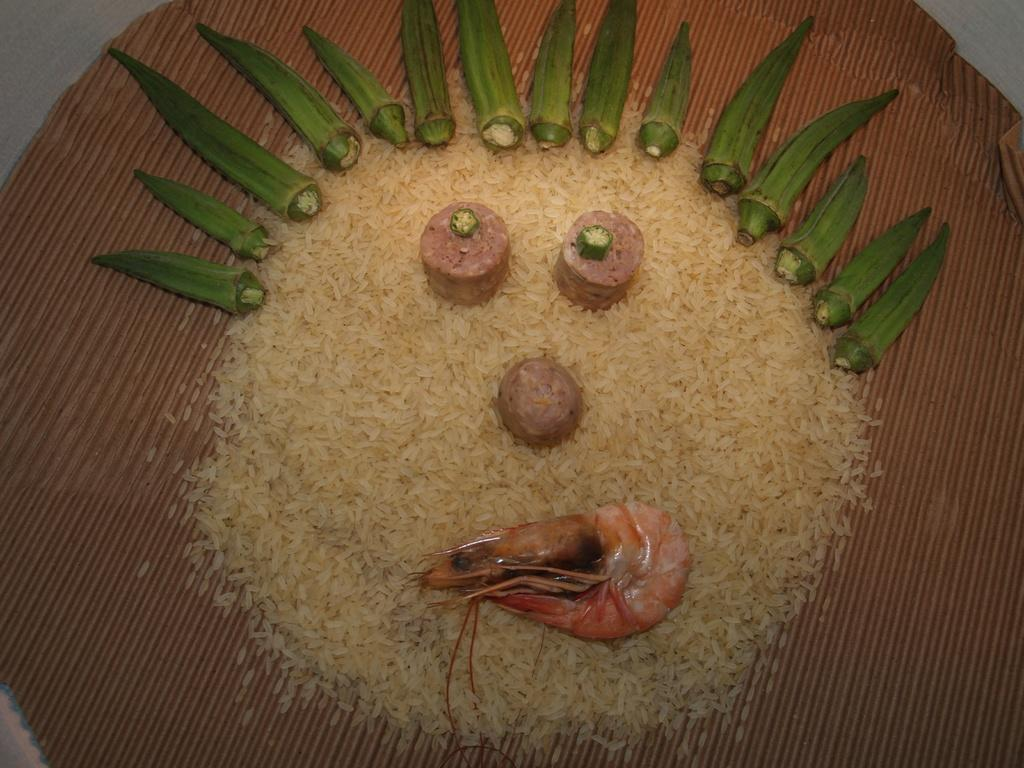What is the color of the surface in the image? The surface in the image is brown colored. What type of food can be seen on the surface? There is rice, ladies fingers, and a prawn on the surface. Are there any other food items visible on the surface? Yes, there are other food items on the surface. What type of stem can be seen in the image? There is no stem present in the image. What invention is being used to cook the food in the image? The provided facts do not mention any cooking method or invention used to prepare the food in the image. 